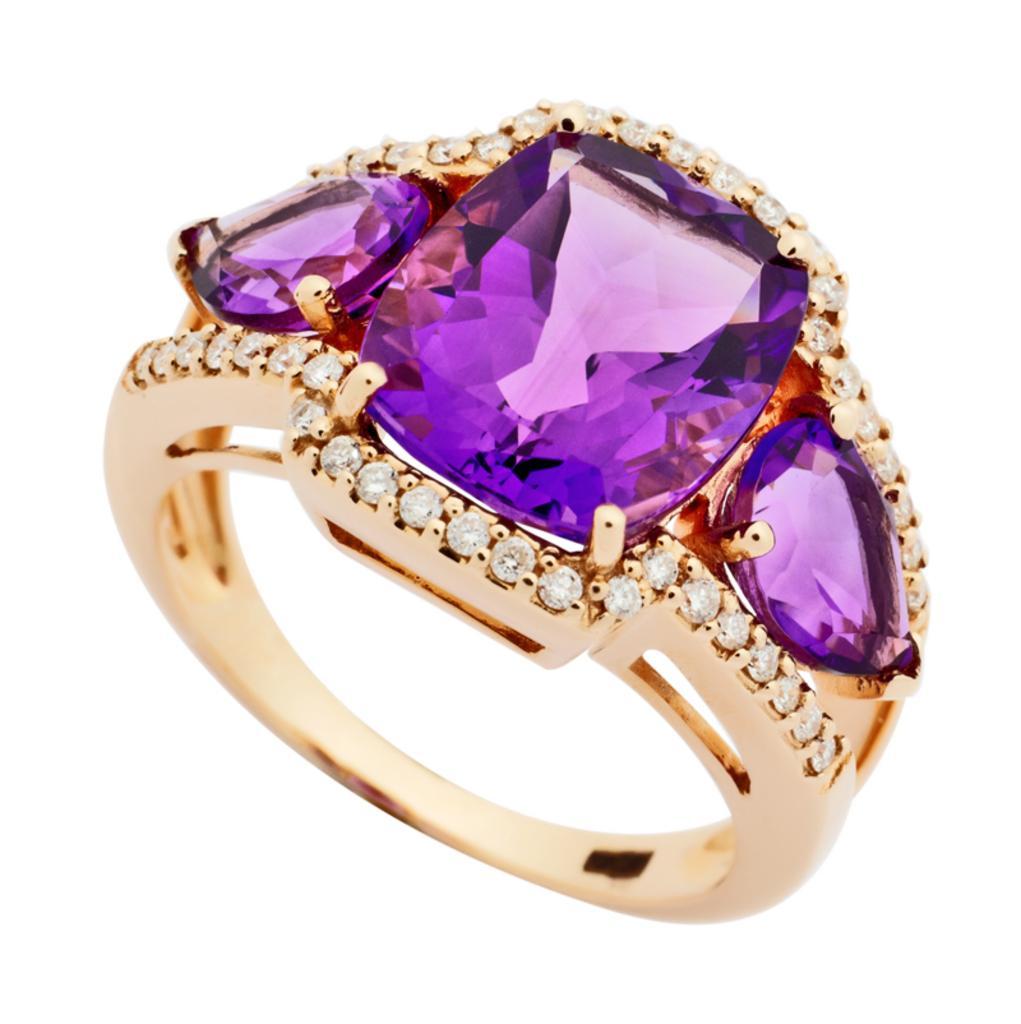Can you describe this image briefly? In this image we can see a ring with some stones. 